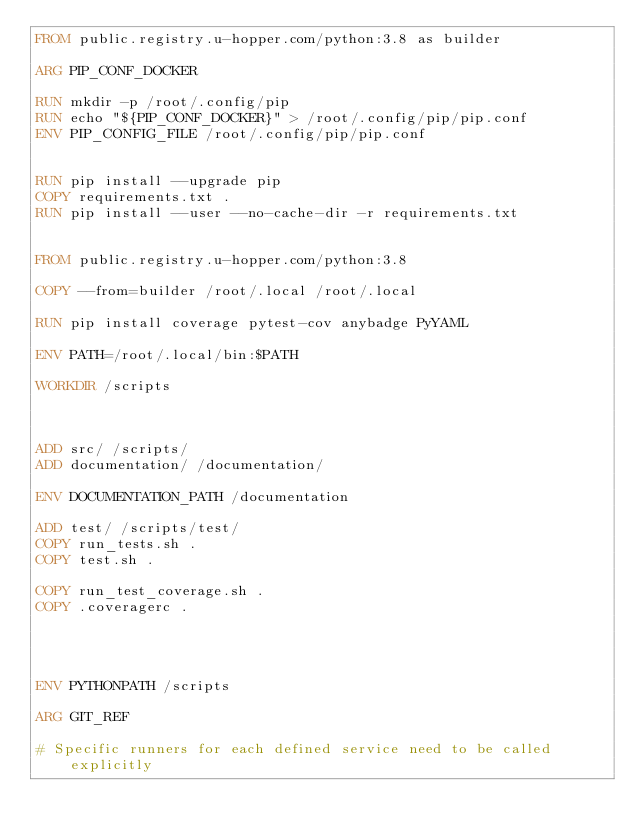Convert code to text. <code><loc_0><loc_0><loc_500><loc_500><_Dockerfile_>FROM public.registry.u-hopper.com/python:3.8 as builder

ARG PIP_CONF_DOCKER

RUN mkdir -p /root/.config/pip
RUN echo "${PIP_CONF_DOCKER}" > /root/.config/pip/pip.conf
ENV PIP_CONFIG_FILE /root/.config/pip/pip.conf


RUN pip install --upgrade pip
COPY requirements.txt .
RUN pip install --user --no-cache-dir -r requirements.txt


FROM public.registry.u-hopper.com/python:3.8

COPY --from=builder /root/.local /root/.local

RUN pip install coverage pytest-cov anybadge PyYAML

ENV PATH=/root/.local/bin:$PATH

WORKDIR /scripts



ADD src/ /scripts/
ADD documentation/ /documentation/

ENV DOCUMENTATION_PATH /documentation

ADD test/ /scripts/test/
COPY run_tests.sh .
COPY test.sh .

COPY run_test_coverage.sh .
COPY .coveragerc .




ENV PYTHONPATH /scripts

ARG GIT_REF

# Specific runners for each defined service need to be called explicitly
</code> 